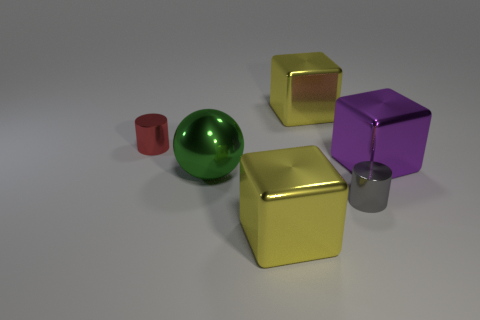Add 4 big blue shiny spheres. How many objects exist? 10 Subtract all cylinders. How many objects are left? 4 Subtract 0 green cubes. How many objects are left? 6 Subtract all balls. Subtract all purple things. How many objects are left? 4 Add 1 cubes. How many cubes are left? 4 Add 3 small green rubber things. How many small green rubber things exist? 3 